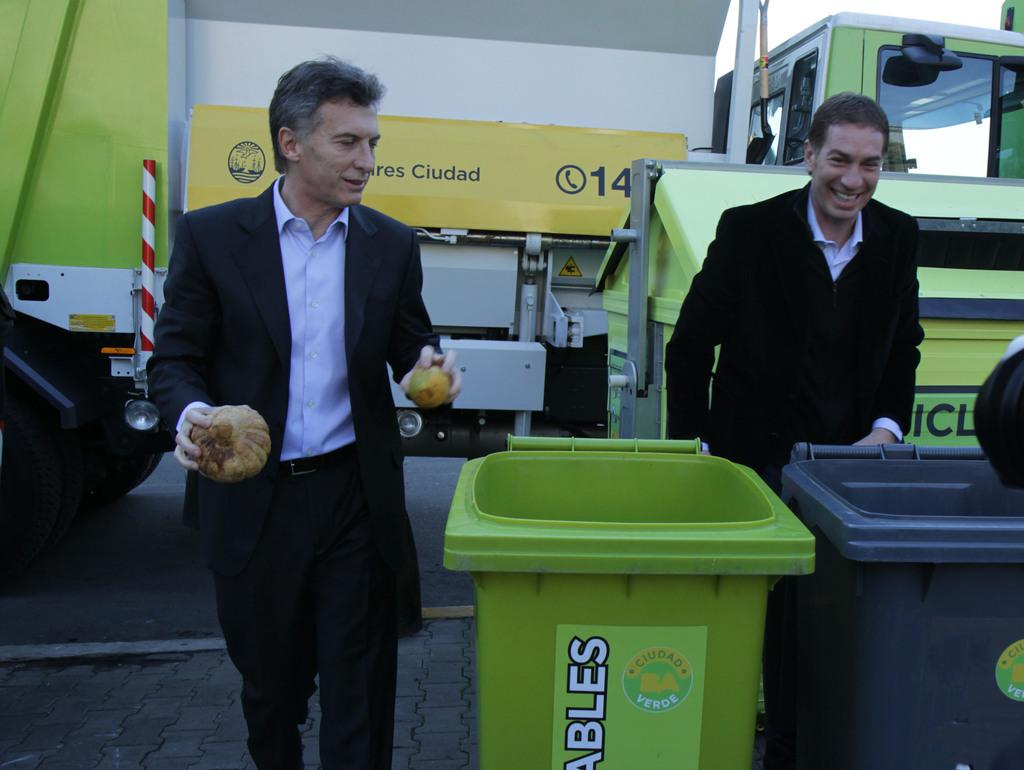<image>
Summarize the visual content of the image. Two men are outside by recyclable trash cans 